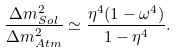Convert formula to latex. <formula><loc_0><loc_0><loc_500><loc_500>\frac { \Delta m ^ { 2 } _ { S o l } } { \Delta m ^ { 2 } _ { A t m } } \simeq \frac { \eta ^ { 4 } ( 1 - \omega ^ { 4 } ) } { 1 - \eta ^ { 4 } } .</formula> 